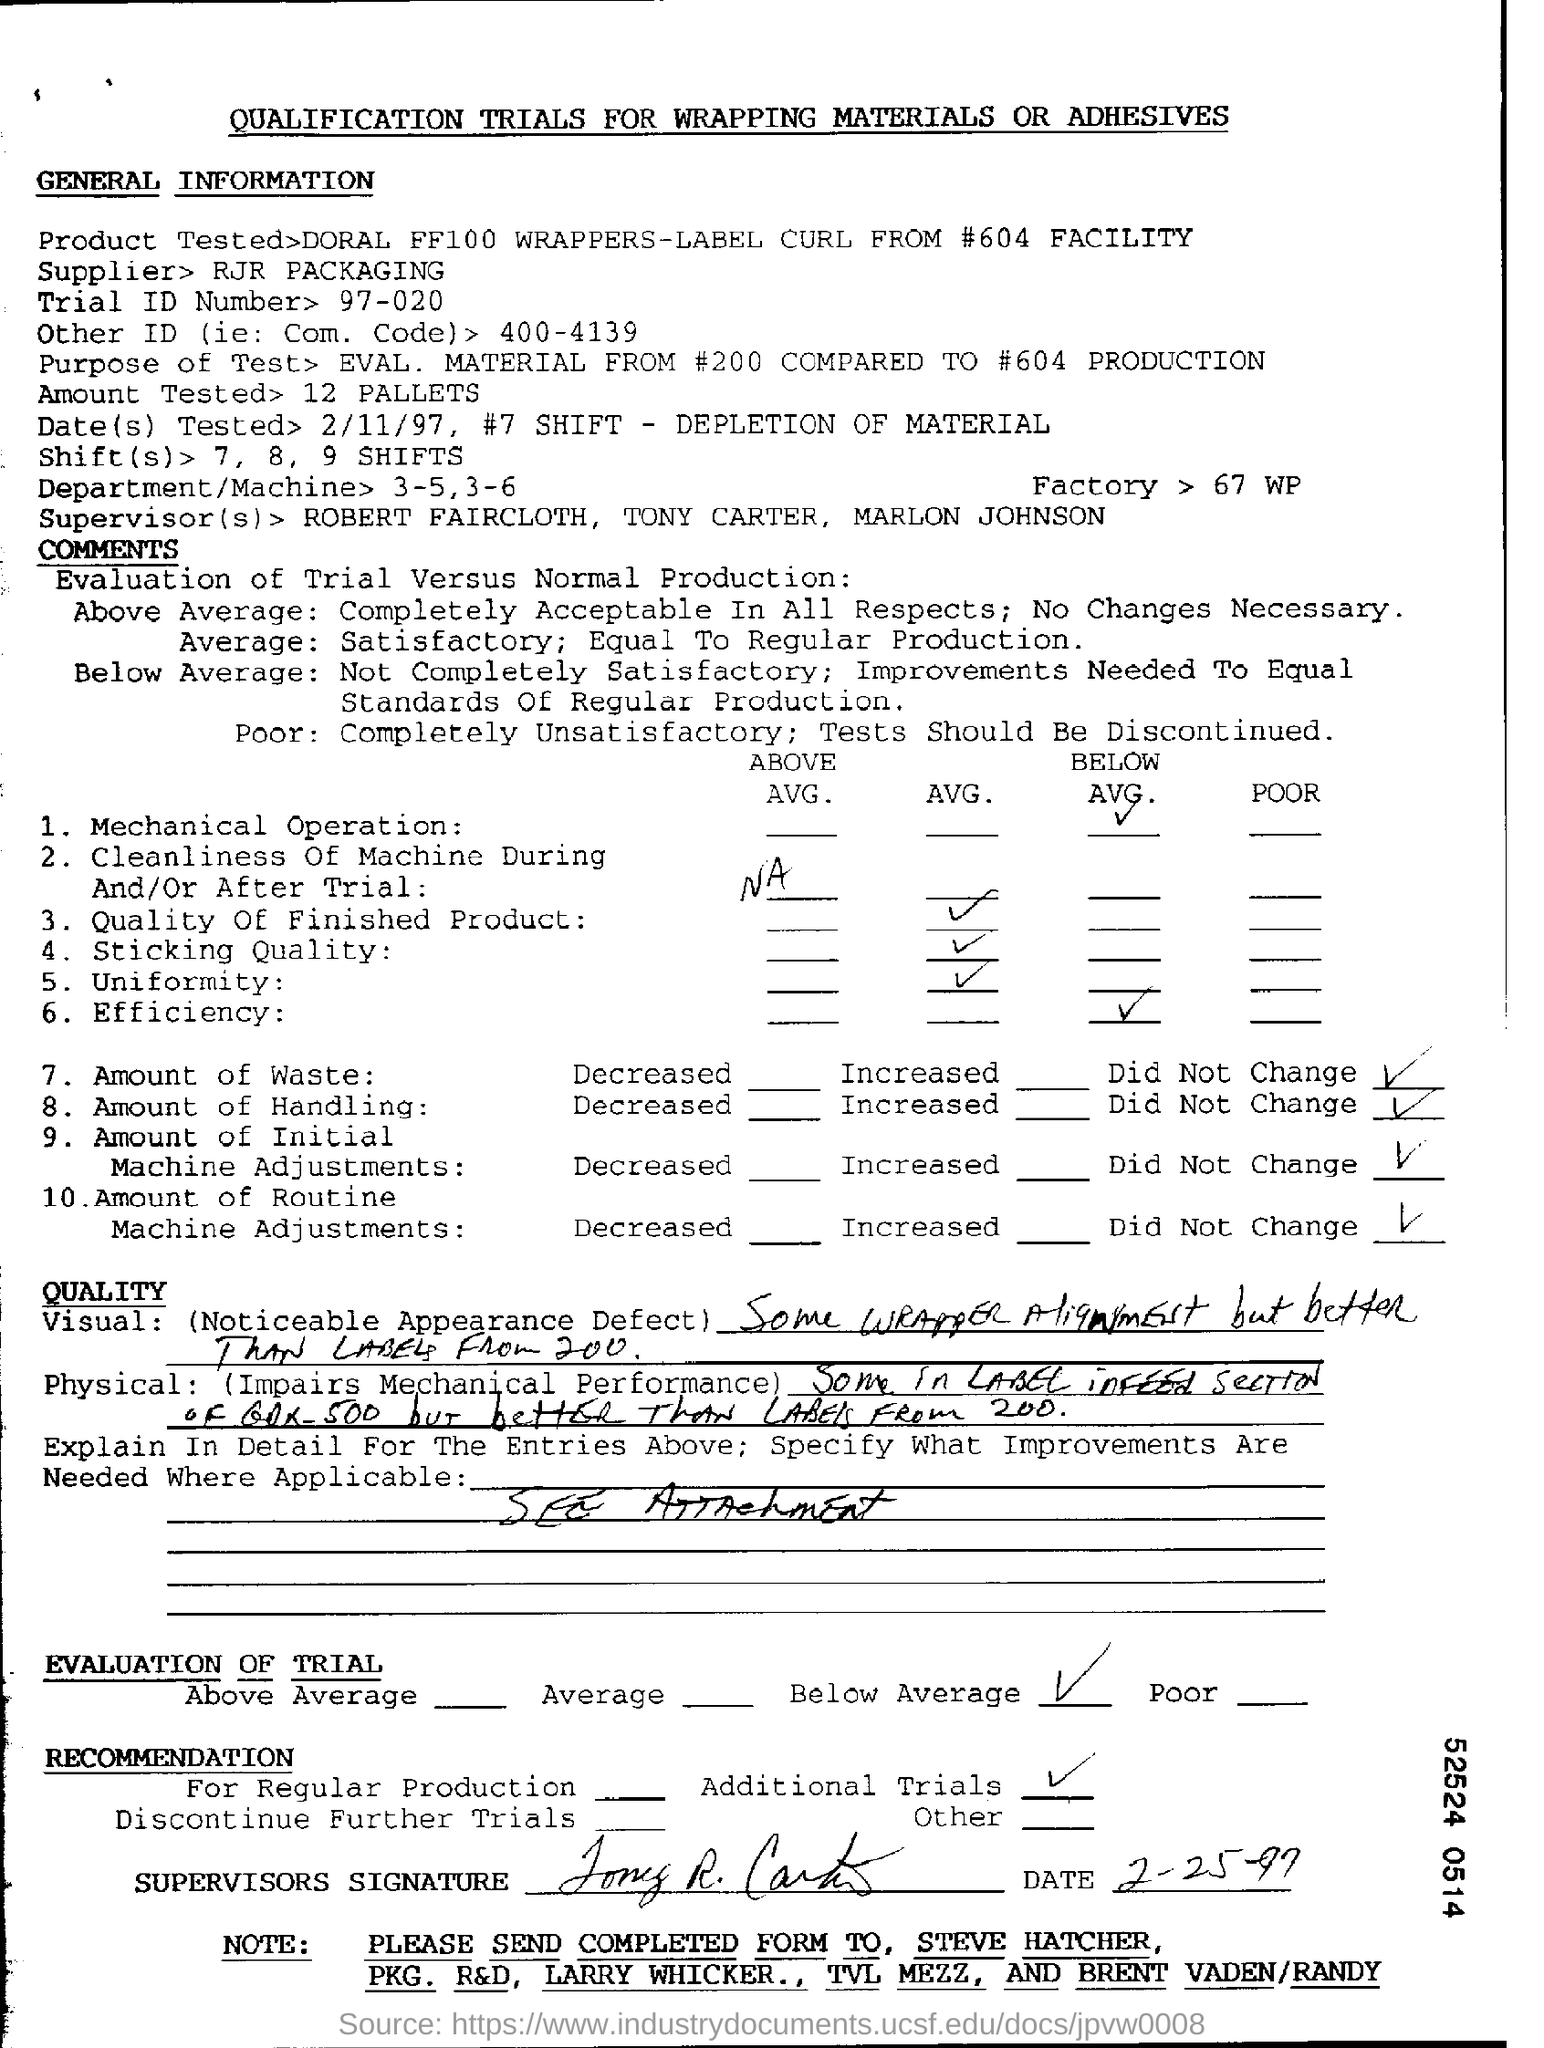Indicate a few pertinent items in this graphic. The Trial ID Number is 97-020... The purpose of the test is to evaluate the material from the #200 compared to the #604 production. 